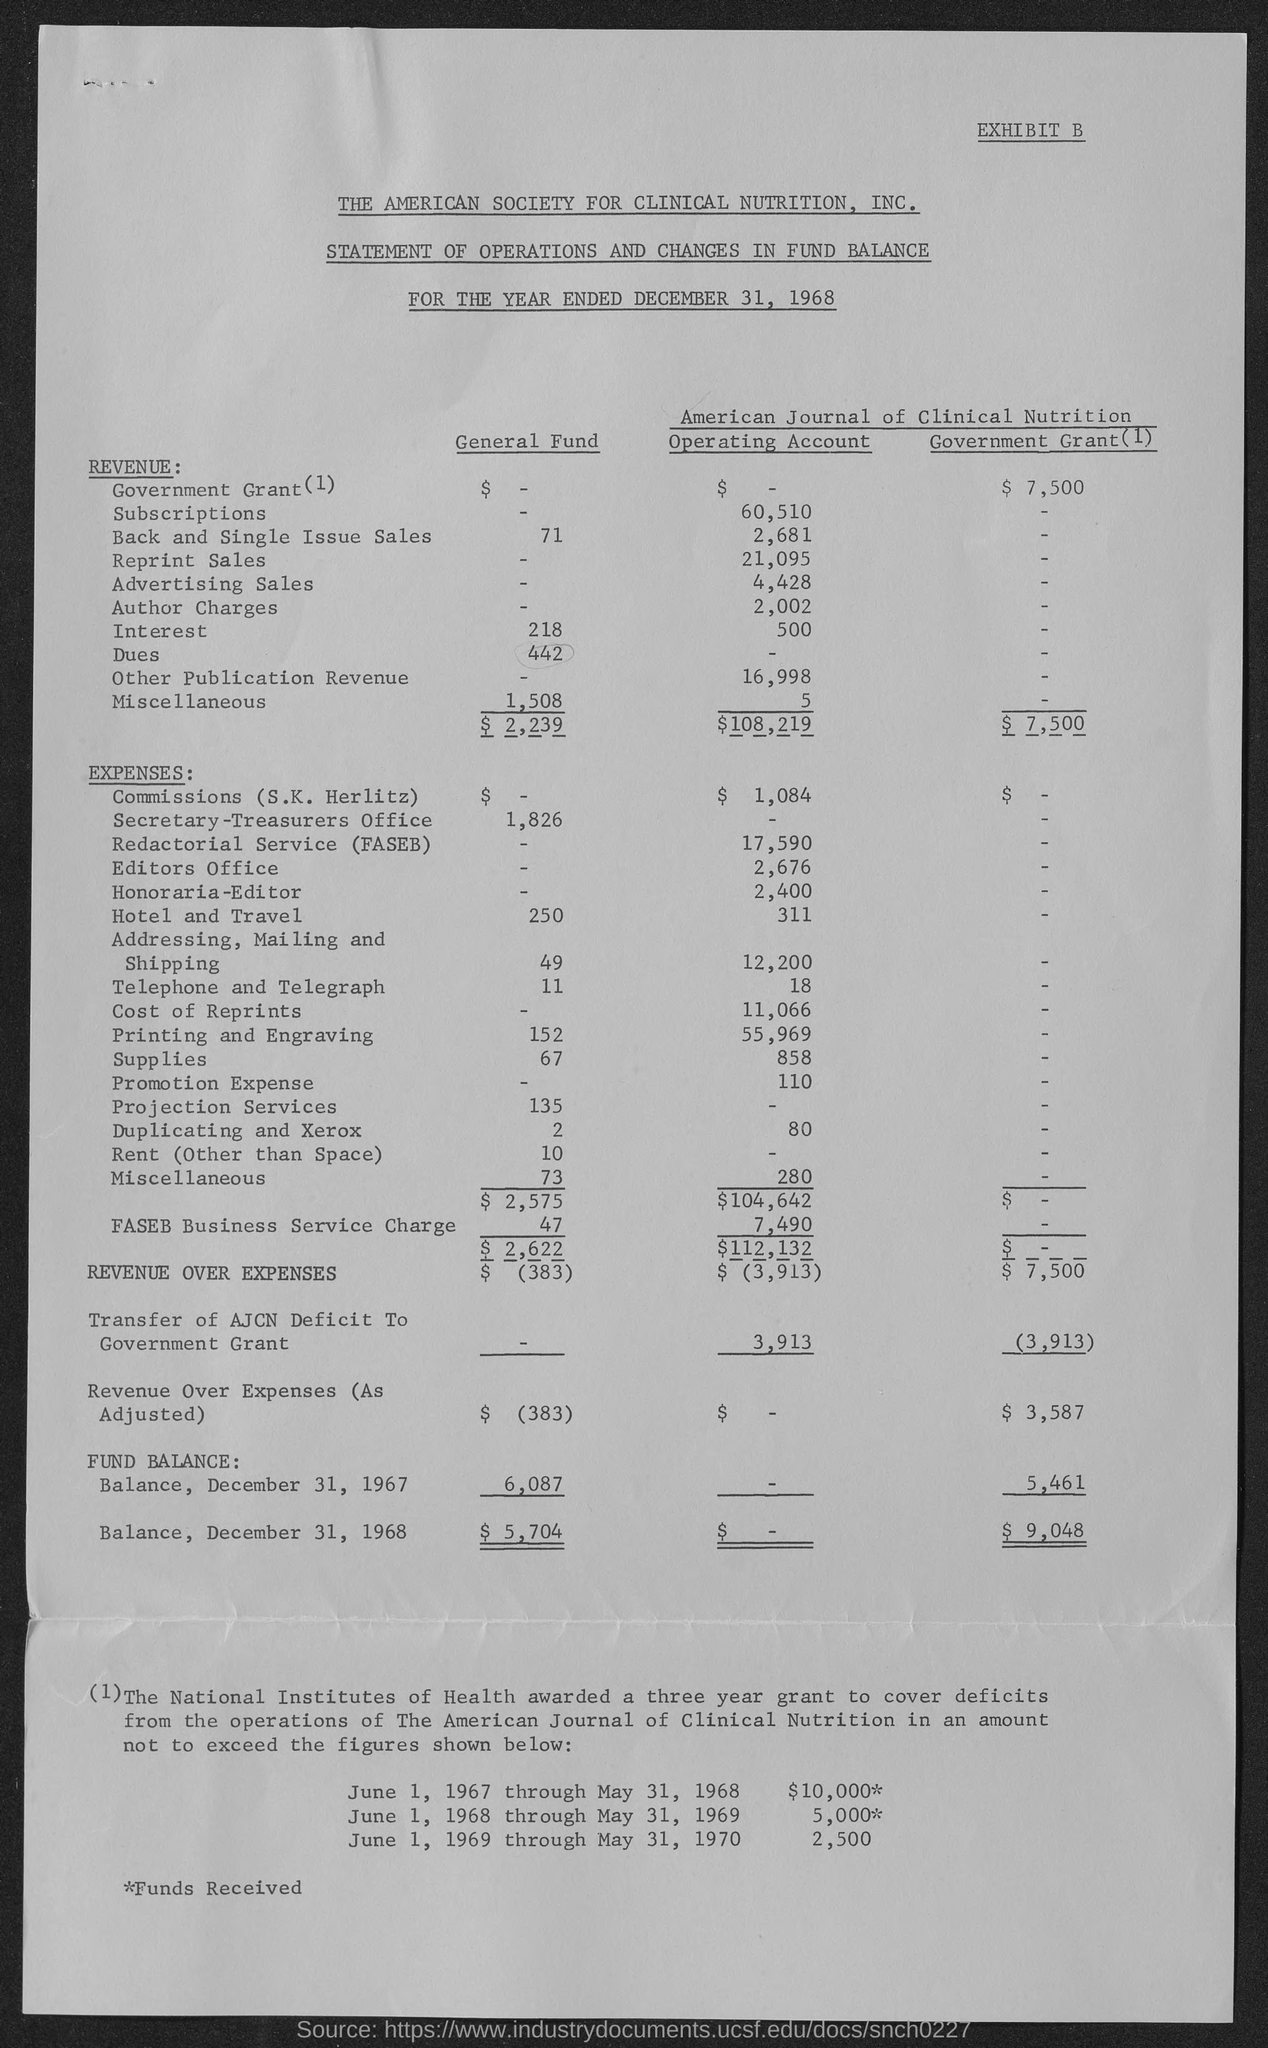What is the total revenue from general fund?
Offer a terse response. $2,239. What is the total revenue from operating account ?
Make the answer very short. $108,219. What is the total revenue from government grant ?
Provide a short and direct response. $ 7,500. What is the revenue over expenses in general fund ?
Provide a succinct answer. $ (383). What is the revenue over expenses in operating account ?
Your response must be concise. 3,913. What is the revenue over expenses in government grant ?
Ensure brevity in your answer.  7,500. 